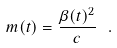<formula> <loc_0><loc_0><loc_500><loc_500>m ( t ) = \frac { \beta ( t ) ^ { 2 } } c \ .</formula> 